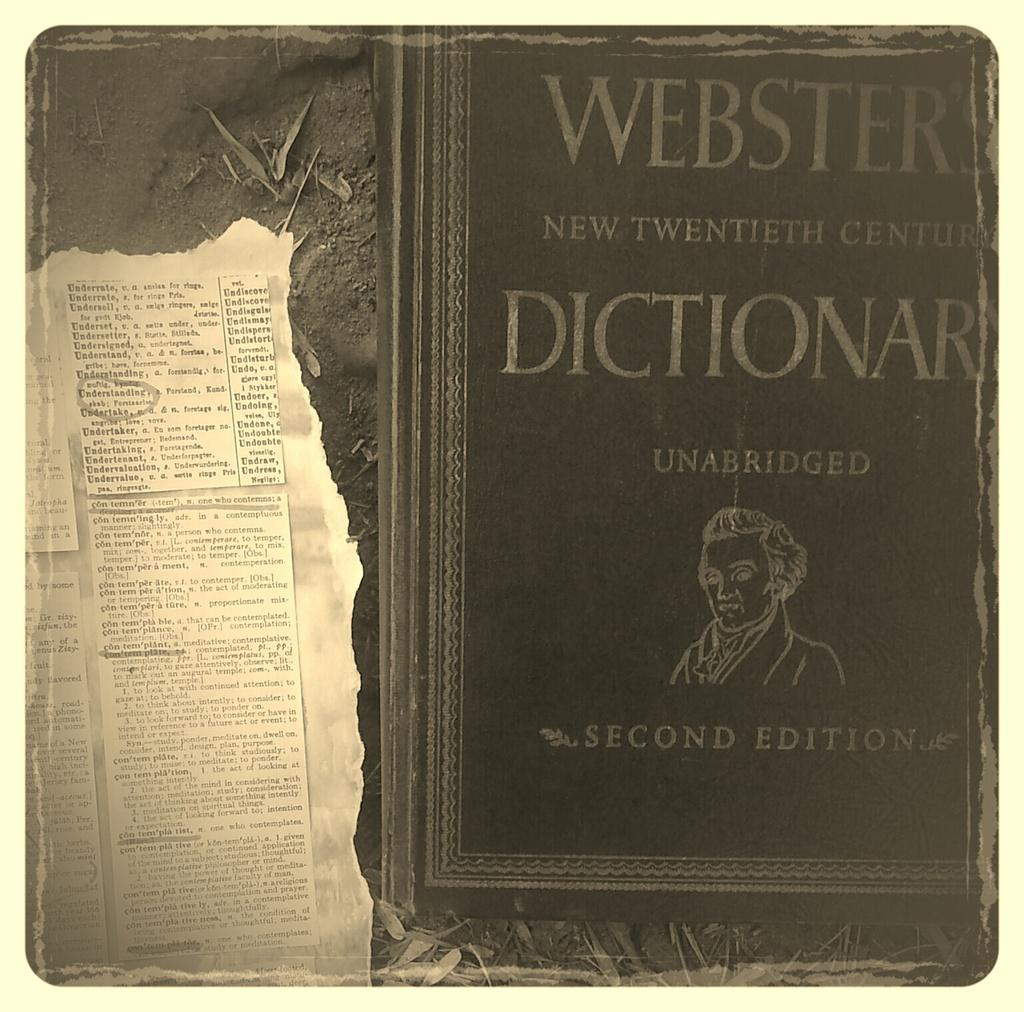<image>
Relay a brief, clear account of the picture shown. A very old copy of a second edition Websters Dictionary is displayed. 